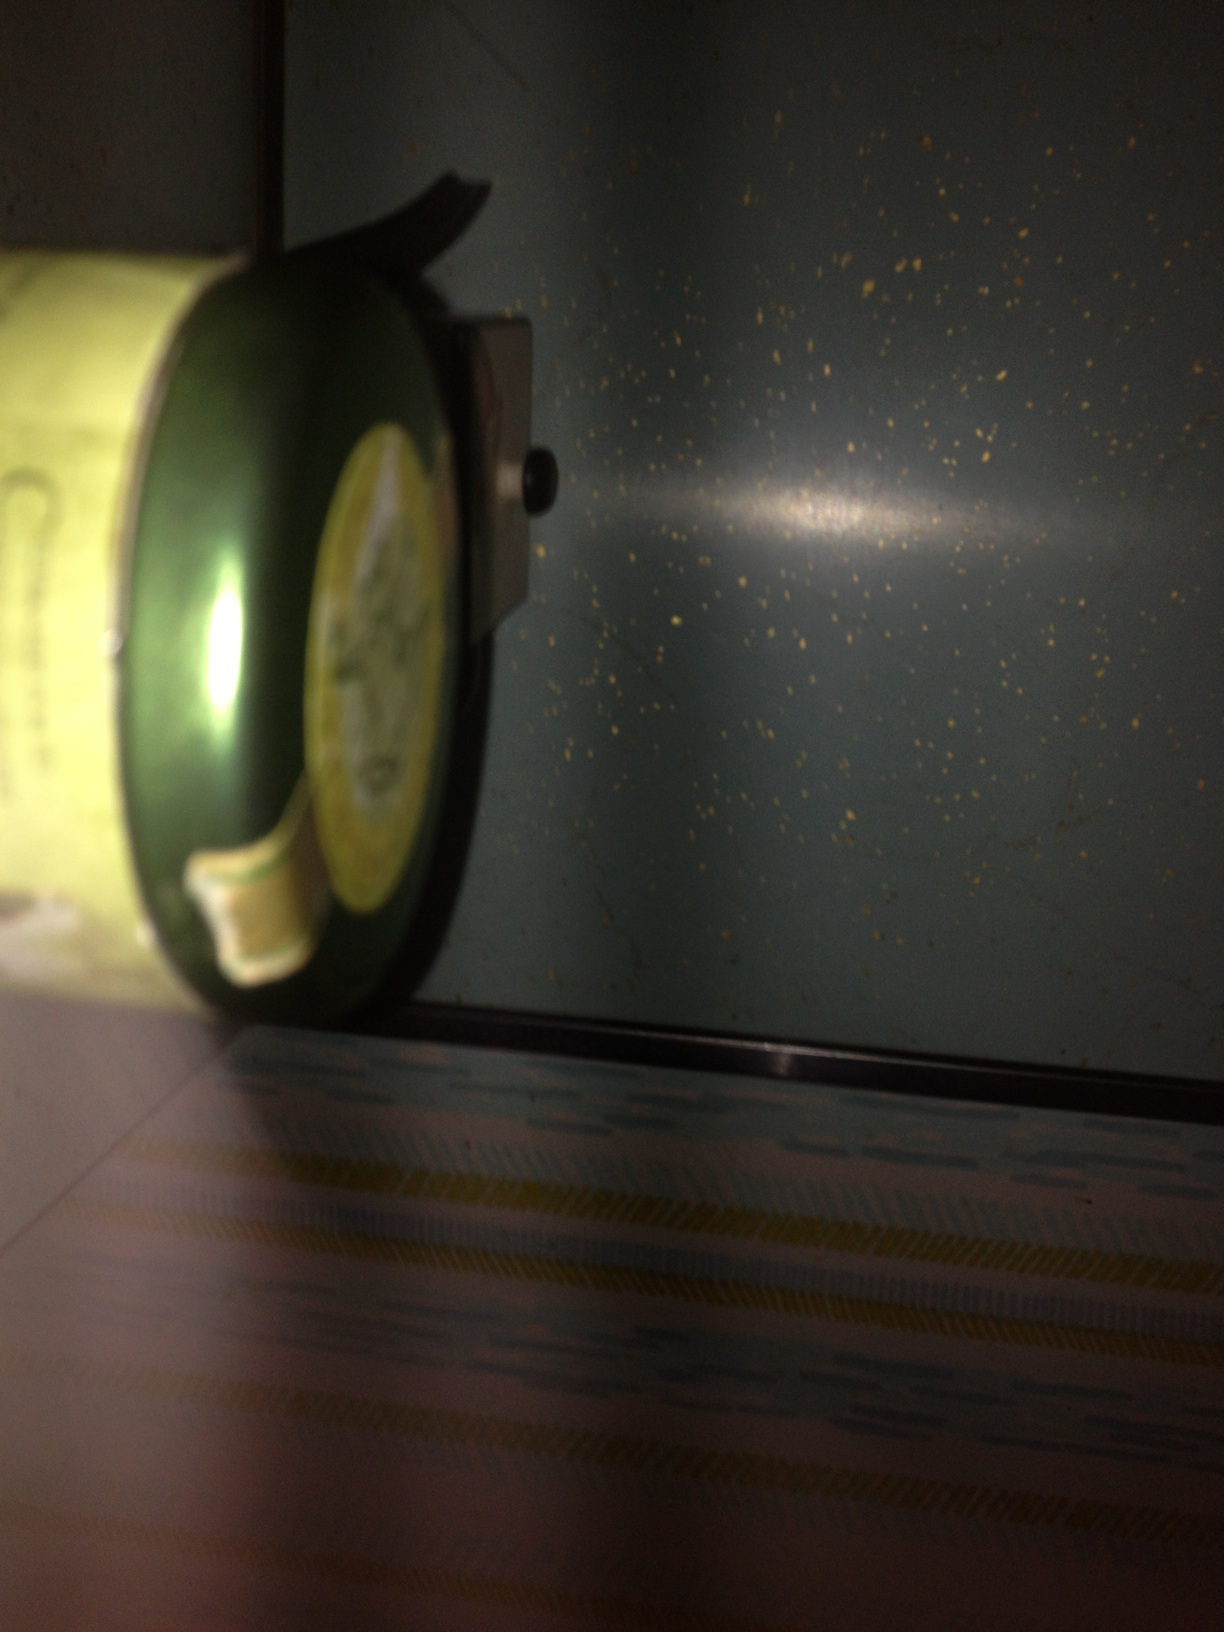Can you describe the object in detail? The image depicts a cylindrical can with a greenish label. The label appears to have some form of tea branding, possibly featuring leaves or a herbal motif. The can is somewhat reflective, suggesting a metallic material, and there might be additional text on the label that is not fully visible in the picture. What flavor teas come in such cans? Teas that come in such cans can vary widely. Common flavors include green tea, black tea, herbal teas such as chamomile or peppermint, and flavored teas like jasmine or lemon. The packaging often aims to maintain the freshness and aroma of the tea leaves. How might one prepare tea from a can like this? To prepare tea from a can like this, follow these steps: 1) Open the can and measure the appropriate amount of tea leaves or tea bags as per the instructions. 2) Boil water to the required temperature – different teas have optimal brewing temperatures. 3) Pour the hot water over the tea leaves in a teapot or cup. 4) Let the tea steep for the recommended time. 5) Remove the tea leaves or bags and enjoy your tea. Adjust steeping time for desired strength. 